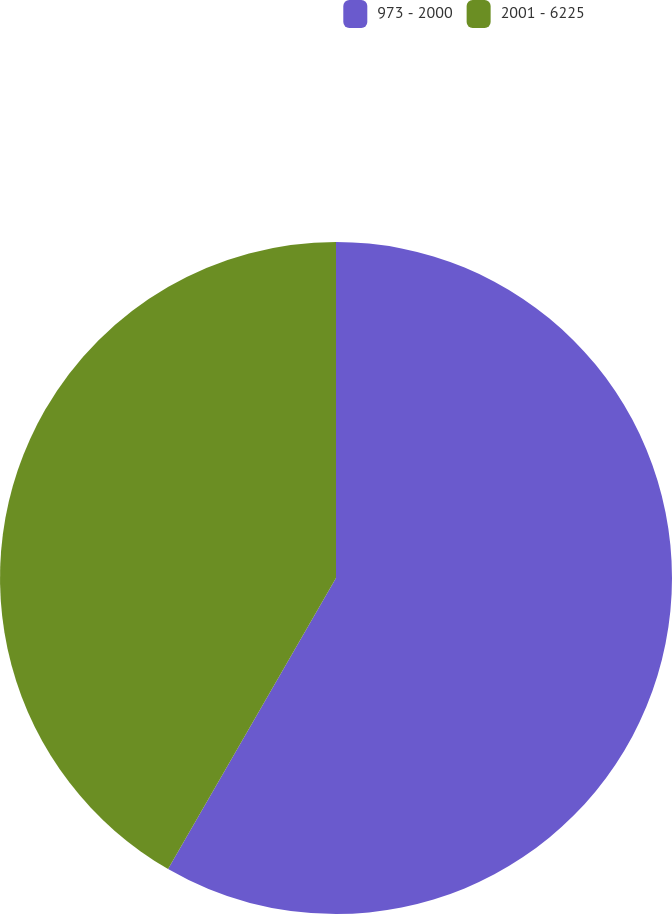Convert chart. <chart><loc_0><loc_0><loc_500><loc_500><pie_chart><fcel>973 - 2000<fcel>2001 - 6225<nl><fcel>58.33%<fcel>41.67%<nl></chart> 